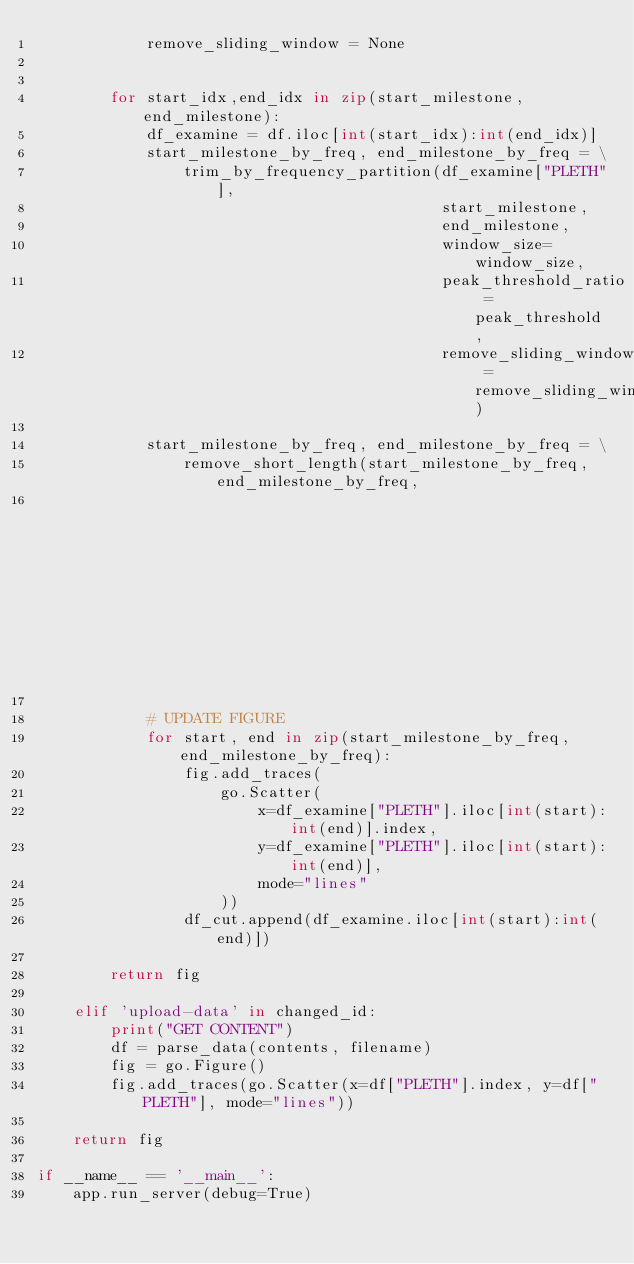<code> <loc_0><loc_0><loc_500><loc_500><_Python_>            remove_sliding_window = None


        for start_idx,end_idx in zip(start_milestone,end_milestone):
            df_examine = df.iloc[int(start_idx):int(end_idx)]
            start_milestone_by_freq, end_milestone_by_freq = \
                trim_by_frequency_partition(df_examine["PLETH"],
                                            start_milestone,
                                            end_milestone,
                                            window_size=window_size,
                                            peak_threshold_ratio = peak_threshold,
                                            remove_sliding_window = remove_sliding_window)

            start_milestone_by_freq, end_milestone_by_freq = \
                remove_short_length(start_milestone_by_freq, end_milestone_by_freq,
                                                                 MIN_MINUTES * 60 * SAMPLE_RATE)

            # UPDATE FIGURE
            for start, end in zip(start_milestone_by_freq, end_milestone_by_freq):
                fig.add_traces(
                    go.Scatter(
                        x=df_examine["PLETH"].iloc[int(start):int(end)].index,
                        y=df_examine["PLETH"].iloc[int(start):int(end)],
                        mode="lines"
                    ))
                df_cut.append(df_examine.iloc[int(start):int(end)])
            
        return fig

    elif 'upload-data' in changed_id:
        print("GET CONTENT")
        df = parse_data(contents, filename)
        fig = go.Figure()
        fig.add_traces(go.Scatter(x=df["PLETH"].index, y=df["PLETH"], mode="lines"))

    return fig

if __name__ == '__main__':
    app.run_server(debug=True)
</code> 